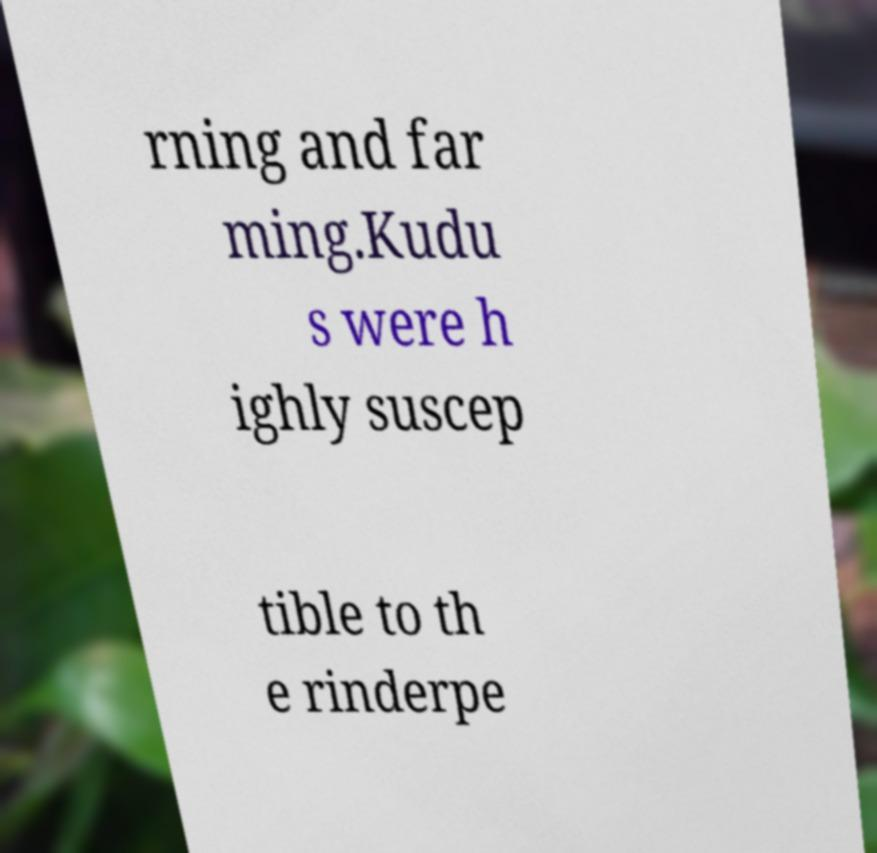Could you assist in decoding the text presented in this image and type it out clearly? rning and far ming.Kudu s were h ighly suscep tible to th e rinderpe 